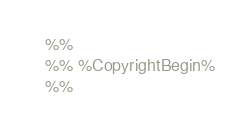Convert code to text. <code><loc_0><loc_0><loc_500><loc_500><_Erlang_>%%
%% %CopyrightBegin%
%% </code> 